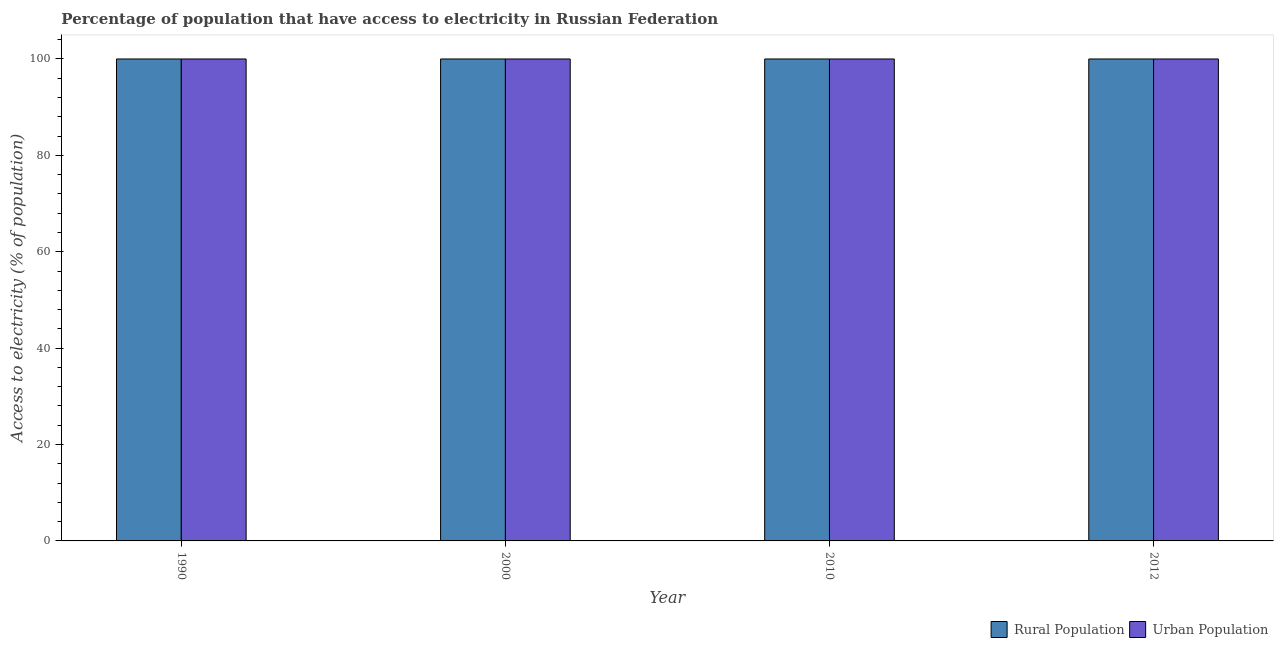How many groups of bars are there?
Keep it short and to the point. 4. Are the number of bars per tick equal to the number of legend labels?
Your answer should be compact. Yes. How many bars are there on the 3rd tick from the left?
Ensure brevity in your answer.  2. What is the label of the 4th group of bars from the left?
Your answer should be compact. 2012. What is the percentage of urban population having access to electricity in 2010?
Your answer should be very brief. 100. Across all years, what is the maximum percentage of rural population having access to electricity?
Offer a terse response. 100. Across all years, what is the minimum percentage of urban population having access to electricity?
Provide a succinct answer. 100. In which year was the percentage of rural population having access to electricity maximum?
Keep it short and to the point. 1990. In which year was the percentage of rural population having access to electricity minimum?
Ensure brevity in your answer.  1990. What is the total percentage of rural population having access to electricity in the graph?
Give a very brief answer. 400. What is the average percentage of urban population having access to electricity per year?
Offer a very short reply. 100. What is the difference between the highest and the second highest percentage of rural population having access to electricity?
Your answer should be compact. 0. What is the difference between the highest and the lowest percentage of rural population having access to electricity?
Offer a terse response. 0. Is the sum of the percentage of urban population having access to electricity in 2000 and 2010 greater than the maximum percentage of rural population having access to electricity across all years?
Make the answer very short. Yes. What does the 1st bar from the left in 1990 represents?
Make the answer very short. Rural Population. What does the 1st bar from the right in 2010 represents?
Provide a short and direct response. Urban Population. Are all the bars in the graph horizontal?
Make the answer very short. No. What is the difference between two consecutive major ticks on the Y-axis?
Ensure brevity in your answer.  20. Are the values on the major ticks of Y-axis written in scientific E-notation?
Provide a succinct answer. No. Where does the legend appear in the graph?
Keep it short and to the point. Bottom right. What is the title of the graph?
Give a very brief answer. Percentage of population that have access to electricity in Russian Federation. Does "% of gross capital formation" appear as one of the legend labels in the graph?
Give a very brief answer. No. What is the label or title of the Y-axis?
Your answer should be compact. Access to electricity (% of population). What is the Access to electricity (% of population) of Urban Population in 2012?
Provide a short and direct response. 100. Across all years, what is the maximum Access to electricity (% of population) of Rural Population?
Provide a short and direct response. 100. Across all years, what is the minimum Access to electricity (% of population) in Urban Population?
Ensure brevity in your answer.  100. What is the difference between the Access to electricity (% of population) in Rural Population in 1990 and that in 2000?
Offer a terse response. 0. What is the difference between the Access to electricity (% of population) of Rural Population in 1990 and that in 2012?
Give a very brief answer. 0. What is the difference between the Access to electricity (% of population) of Urban Population in 1990 and that in 2012?
Your answer should be very brief. 0. What is the difference between the Access to electricity (% of population) of Rural Population in 2000 and that in 2012?
Give a very brief answer. 0. What is the difference between the Access to electricity (% of population) of Urban Population in 2000 and that in 2012?
Offer a terse response. 0. What is the difference between the Access to electricity (% of population) of Urban Population in 2010 and that in 2012?
Keep it short and to the point. 0. What is the difference between the Access to electricity (% of population) of Rural Population in 1990 and the Access to electricity (% of population) of Urban Population in 2000?
Offer a very short reply. 0. What is the difference between the Access to electricity (% of population) in Rural Population in 2000 and the Access to electricity (% of population) in Urban Population in 2010?
Your answer should be very brief. 0. What is the difference between the Access to electricity (% of population) of Rural Population in 2000 and the Access to electricity (% of population) of Urban Population in 2012?
Ensure brevity in your answer.  0. What is the average Access to electricity (% of population) in Rural Population per year?
Make the answer very short. 100. In the year 1990, what is the difference between the Access to electricity (% of population) in Rural Population and Access to electricity (% of population) in Urban Population?
Provide a short and direct response. 0. In the year 2000, what is the difference between the Access to electricity (% of population) in Rural Population and Access to electricity (% of population) in Urban Population?
Your answer should be compact. 0. In the year 2010, what is the difference between the Access to electricity (% of population) in Rural Population and Access to electricity (% of population) in Urban Population?
Your answer should be very brief. 0. In the year 2012, what is the difference between the Access to electricity (% of population) of Rural Population and Access to electricity (% of population) of Urban Population?
Make the answer very short. 0. What is the ratio of the Access to electricity (% of population) in Urban Population in 1990 to that in 2000?
Your answer should be compact. 1. What is the ratio of the Access to electricity (% of population) in Rural Population in 1990 to that in 2010?
Keep it short and to the point. 1. What is the ratio of the Access to electricity (% of population) of Urban Population in 1990 to that in 2010?
Your response must be concise. 1. What is the ratio of the Access to electricity (% of population) in Rural Population in 2000 to that in 2010?
Make the answer very short. 1. What is the ratio of the Access to electricity (% of population) of Urban Population in 2000 to that in 2010?
Your answer should be very brief. 1. What is the ratio of the Access to electricity (% of population) in Rural Population in 2000 to that in 2012?
Your response must be concise. 1. What is the ratio of the Access to electricity (% of population) of Rural Population in 2010 to that in 2012?
Keep it short and to the point. 1. What is the difference between the highest and the lowest Access to electricity (% of population) of Rural Population?
Keep it short and to the point. 0. 